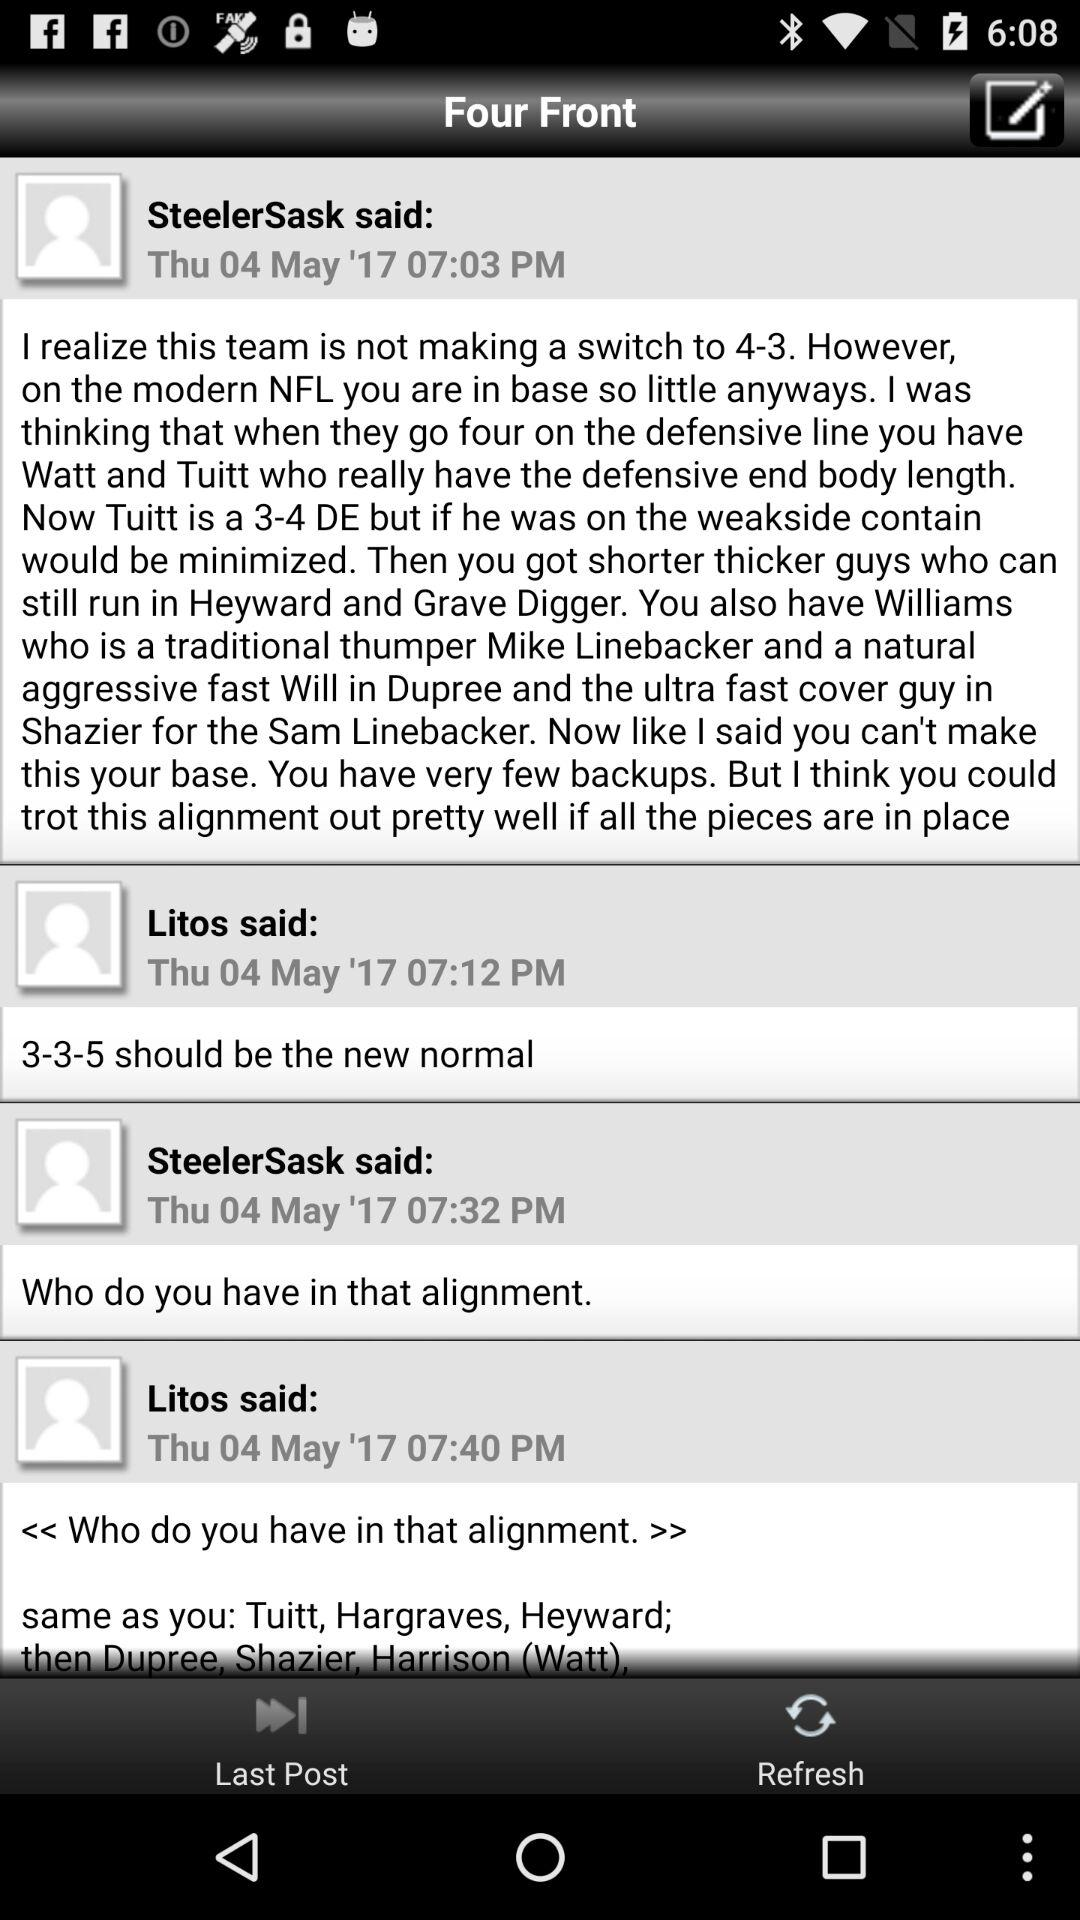How many posts are in the thread?
Answer the question using a single word or phrase. 3 